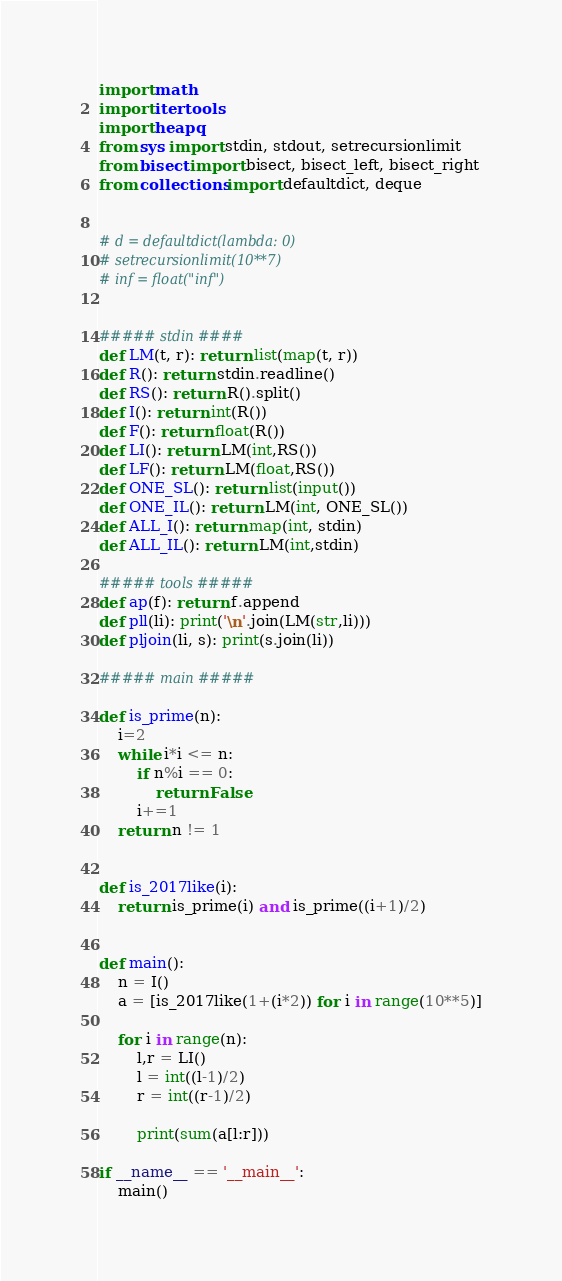<code> <loc_0><loc_0><loc_500><loc_500><_Python_>import math
import itertools
import heapq
from sys import stdin, stdout, setrecursionlimit
from bisect import bisect, bisect_left, bisect_right
from collections import defaultdict, deque


# d = defaultdict(lambda: 0)
# setrecursionlimit(10**7)
# inf = float("inf")


##### stdin ####
def LM(t, r): return list(map(t, r))
def R(): return stdin.readline()
def RS(): return R().split()
def I(): return int(R())
def F(): return float(R())
def LI(): return LM(int,RS())
def LF(): return LM(float,RS())
def ONE_SL(): return list(input())
def ONE_IL(): return LM(int, ONE_SL())
def ALL_I(): return map(int, stdin)
def ALL_IL(): return LM(int,stdin)

##### tools #####
def ap(f): return f.append
def pll(li): print('\n'.join(LM(str,li)))
def pljoin(li, s): print(s.join(li))

##### main #####

def is_prime(n):
    i=2
    while i*i <= n:
        if n%i == 0:
            return False
        i+=1
    return n != 1


def is_2017like(i):
	return is_prime(i) and is_prime((i+1)/2)


def main():
	n = I()
	a = [is_2017like(1+(i*2)) for i in range(10**5)]

	for i in range(n):
		l,r = LI()
		l = int((l-1)/2)
		r = int((r-1)/2)

		print(sum(a[l:r]))
	
if __name__ == '__main__':
	main()</code> 